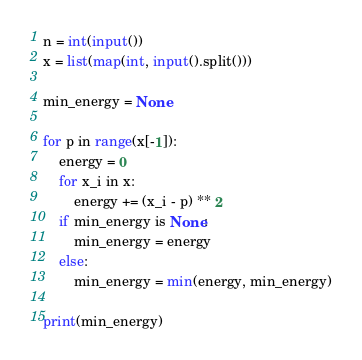Convert code to text. <code><loc_0><loc_0><loc_500><loc_500><_Python_>n = int(input())
x = list(map(int, input().split()))

min_energy = None

for p in range(x[-1]):
    energy = 0
    for x_i in x:
        energy += (x_i - p) ** 2
    if min_energy is None:
        min_energy = energy
    else:
        min_energy = min(energy, min_energy)

print(min_energy)
</code> 